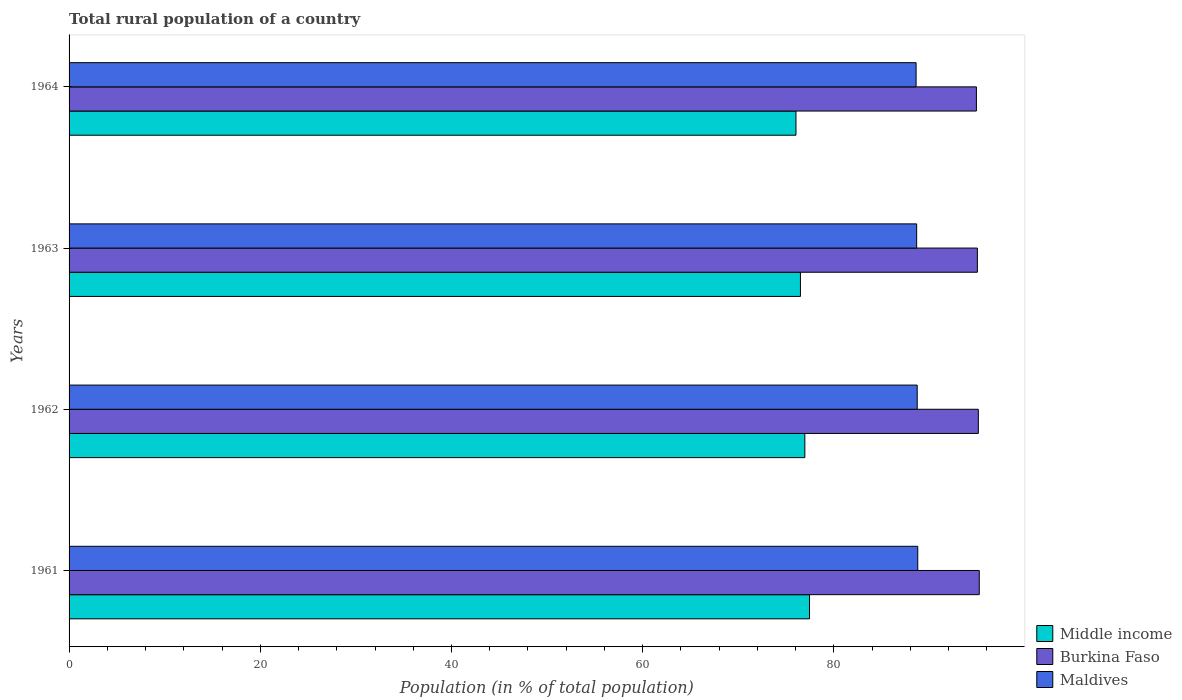How many bars are there on the 4th tick from the top?
Offer a very short reply. 3. How many bars are there on the 3rd tick from the bottom?
Your response must be concise. 3. What is the label of the 1st group of bars from the top?
Your answer should be very brief. 1964. What is the rural population in Burkina Faso in 1963?
Keep it short and to the point. 95.01. Across all years, what is the maximum rural population in Middle income?
Offer a terse response. 77.45. Across all years, what is the minimum rural population in Burkina Faso?
Your answer should be very brief. 94.91. In which year was the rural population in Maldives minimum?
Provide a succinct answer. 1964. What is the total rural population in Maldives in the graph?
Keep it short and to the point. 354.73. What is the difference between the rural population in Middle income in 1962 and that in 1963?
Keep it short and to the point. 0.46. What is the difference between the rural population in Maldives in 1962 and the rural population in Middle income in 1963?
Ensure brevity in your answer.  12.21. What is the average rural population in Burkina Faso per year?
Your response must be concise. 95.06. In the year 1964, what is the difference between the rural population in Burkina Faso and rural population in Maldives?
Make the answer very short. 6.31. In how many years, is the rural population in Maldives greater than 32 %?
Keep it short and to the point. 4. What is the ratio of the rural population in Burkina Faso in 1961 to that in 1964?
Give a very brief answer. 1. Is the rural population in Maldives in 1962 less than that in 1963?
Offer a terse response. No. What is the difference between the highest and the second highest rural population in Burkina Faso?
Your answer should be very brief. 0.1. What is the difference between the highest and the lowest rural population in Middle income?
Ensure brevity in your answer.  1.42. In how many years, is the rural population in Burkina Faso greater than the average rural population in Burkina Faso taken over all years?
Ensure brevity in your answer.  2. Is the sum of the rural population in Middle income in 1961 and 1963 greater than the maximum rural population in Burkina Faso across all years?
Make the answer very short. Yes. What does the 1st bar from the top in 1964 represents?
Give a very brief answer. Maldives. What does the 2nd bar from the bottom in 1964 represents?
Your response must be concise. Burkina Faso. How many years are there in the graph?
Your response must be concise. 4. Does the graph contain any zero values?
Ensure brevity in your answer.  No. Where does the legend appear in the graph?
Ensure brevity in your answer.  Bottom right. How are the legend labels stacked?
Keep it short and to the point. Vertical. What is the title of the graph?
Keep it short and to the point. Total rural population of a country. What is the label or title of the X-axis?
Your response must be concise. Population (in % of total population). What is the Population (in % of total population) of Middle income in 1961?
Ensure brevity in your answer.  77.45. What is the Population (in % of total population) of Burkina Faso in 1961?
Your answer should be compact. 95.2. What is the Population (in % of total population) in Maldives in 1961?
Give a very brief answer. 88.77. What is the Population (in % of total population) in Middle income in 1962?
Provide a short and direct response. 76.96. What is the Population (in % of total population) of Burkina Faso in 1962?
Ensure brevity in your answer.  95.11. What is the Population (in % of total population) in Maldives in 1962?
Ensure brevity in your answer.  88.71. What is the Population (in % of total population) in Middle income in 1963?
Your response must be concise. 76.5. What is the Population (in % of total population) of Burkina Faso in 1963?
Your answer should be compact. 95.01. What is the Population (in % of total population) in Maldives in 1963?
Provide a succinct answer. 88.66. What is the Population (in % of total population) in Middle income in 1964?
Your answer should be compact. 76.03. What is the Population (in % of total population) of Burkina Faso in 1964?
Your answer should be very brief. 94.91. What is the Population (in % of total population) of Maldives in 1964?
Give a very brief answer. 88.6. Across all years, what is the maximum Population (in % of total population) of Middle income?
Your answer should be compact. 77.45. Across all years, what is the maximum Population (in % of total population) in Burkina Faso?
Offer a terse response. 95.2. Across all years, what is the maximum Population (in % of total population) in Maldives?
Your answer should be compact. 88.77. Across all years, what is the minimum Population (in % of total population) of Middle income?
Your response must be concise. 76.03. Across all years, what is the minimum Population (in % of total population) in Burkina Faso?
Provide a short and direct response. 94.91. Across all years, what is the minimum Population (in % of total population) in Maldives?
Offer a terse response. 88.6. What is the total Population (in % of total population) in Middle income in the graph?
Provide a succinct answer. 306.94. What is the total Population (in % of total population) in Burkina Faso in the graph?
Keep it short and to the point. 380.22. What is the total Population (in % of total population) of Maldives in the graph?
Offer a very short reply. 354.73. What is the difference between the Population (in % of total population) in Middle income in 1961 and that in 1962?
Make the answer very short. 0.49. What is the difference between the Population (in % of total population) in Burkina Faso in 1961 and that in 1962?
Give a very brief answer. 0.1. What is the difference between the Population (in % of total population) in Maldives in 1961 and that in 1962?
Provide a succinct answer. 0.06. What is the difference between the Population (in % of total population) in Middle income in 1961 and that in 1963?
Provide a short and direct response. 0.95. What is the difference between the Population (in % of total population) of Burkina Faso in 1961 and that in 1963?
Offer a terse response. 0.2. What is the difference between the Population (in % of total population) in Maldives in 1961 and that in 1963?
Your answer should be very brief. 0.12. What is the difference between the Population (in % of total population) of Middle income in 1961 and that in 1964?
Your answer should be compact. 1.42. What is the difference between the Population (in % of total population) of Burkina Faso in 1961 and that in 1964?
Your response must be concise. 0.3. What is the difference between the Population (in % of total population) in Maldives in 1961 and that in 1964?
Provide a short and direct response. 0.17. What is the difference between the Population (in % of total population) of Middle income in 1962 and that in 1963?
Make the answer very short. 0.46. What is the difference between the Population (in % of total population) of Burkina Faso in 1962 and that in 1963?
Offer a very short reply. 0.1. What is the difference between the Population (in % of total population) in Maldives in 1962 and that in 1963?
Give a very brief answer. 0.06. What is the difference between the Population (in % of total population) in Middle income in 1962 and that in 1964?
Ensure brevity in your answer.  0.93. What is the difference between the Population (in % of total population) in Burkina Faso in 1962 and that in 1964?
Provide a short and direct response. 0.2. What is the difference between the Population (in % of total population) in Maldives in 1962 and that in 1964?
Provide a short and direct response. 0.12. What is the difference between the Population (in % of total population) of Middle income in 1963 and that in 1964?
Keep it short and to the point. 0.47. What is the difference between the Population (in % of total population) in Burkina Faso in 1963 and that in 1964?
Make the answer very short. 0.1. What is the difference between the Population (in % of total population) of Maldives in 1963 and that in 1964?
Keep it short and to the point. 0.06. What is the difference between the Population (in % of total population) in Middle income in 1961 and the Population (in % of total population) in Burkina Faso in 1962?
Keep it short and to the point. -17.66. What is the difference between the Population (in % of total population) of Middle income in 1961 and the Population (in % of total population) of Maldives in 1962?
Make the answer very short. -11.27. What is the difference between the Population (in % of total population) of Burkina Faso in 1961 and the Population (in % of total population) of Maldives in 1962?
Offer a very short reply. 6.49. What is the difference between the Population (in % of total population) of Middle income in 1961 and the Population (in % of total population) of Burkina Faso in 1963?
Your answer should be compact. -17.56. What is the difference between the Population (in % of total population) of Middle income in 1961 and the Population (in % of total population) of Maldives in 1963?
Make the answer very short. -11.21. What is the difference between the Population (in % of total population) of Burkina Faso in 1961 and the Population (in % of total population) of Maldives in 1963?
Offer a very short reply. 6.55. What is the difference between the Population (in % of total population) of Middle income in 1961 and the Population (in % of total population) of Burkina Faso in 1964?
Offer a very short reply. -17.46. What is the difference between the Population (in % of total population) in Middle income in 1961 and the Population (in % of total population) in Maldives in 1964?
Make the answer very short. -11.15. What is the difference between the Population (in % of total population) in Burkina Faso in 1961 and the Population (in % of total population) in Maldives in 1964?
Keep it short and to the point. 6.61. What is the difference between the Population (in % of total population) in Middle income in 1962 and the Population (in % of total population) in Burkina Faso in 1963?
Keep it short and to the point. -18.05. What is the difference between the Population (in % of total population) of Middle income in 1962 and the Population (in % of total population) of Maldives in 1963?
Offer a very short reply. -11.69. What is the difference between the Population (in % of total population) in Burkina Faso in 1962 and the Population (in % of total population) in Maldives in 1963?
Offer a very short reply. 6.45. What is the difference between the Population (in % of total population) of Middle income in 1962 and the Population (in % of total population) of Burkina Faso in 1964?
Give a very brief answer. -17.94. What is the difference between the Population (in % of total population) of Middle income in 1962 and the Population (in % of total population) of Maldives in 1964?
Offer a terse response. -11.64. What is the difference between the Population (in % of total population) in Burkina Faso in 1962 and the Population (in % of total population) in Maldives in 1964?
Offer a terse response. 6.51. What is the difference between the Population (in % of total population) in Middle income in 1963 and the Population (in % of total population) in Burkina Faso in 1964?
Your response must be concise. -18.4. What is the difference between the Population (in % of total population) of Middle income in 1963 and the Population (in % of total population) of Maldives in 1964?
Provide a short and direct response. -12.1. What is the difference between the Population (in % of total population) in Burkina Faso in 1963 and the Population (in % of total population) in Maldives in 1964?
Give a very brief answer. 6.41. What is the average Population (in % of total population) in Middle income per year?
Ensure brevity in your answer.  76.73. What is the average Population (in % of total population) in Burkina Faso per year?
Offer a terse response. 95.06. What is the average Population (in % of total population) of Maldives per year?
Keep it short and to the point. 88.68. In the year 1961, what is the difference between the Population (in % of total population) of Middle income and Population (in % of total population) of Burkina Faso?
Ensure brevity in your answer.  -17.76. In the year 1961, what is the difference between the Population (in % of total population) of Middle income and Population (in % of total population) of Maldives?
Make the answer very short. -11.32. In the year 1961, what is the difference between the Population (in % of total population) of Burkina Faso and Population (in % of total population) of Maldives?
Provide a succinct answer. 6.43. In the year 1962, what is the difference between the Population (in % of total population) of Middle income and Population (in % of total population) of Burkina Faso?
Your answer should be very brief. -18.15. In the year 1962, what is the difference between the Population (in % of total population) of Middle income and Population (in % of total population) of Maldives?
Provide a succinct answer. -11.75. In the year 1962, what is the difference between the Population (in % of total population) in Burkina Faso and Population (in % of total population) in Maldives?
Make the answer very short. 6.39. In the year 1963, what is the difference between the Population (in % of total population) in Middle income and Population (in % of total population) in Burkina Faso?
Provide a short and direct response. -18.51. In the year 1963, what is the difference between the Population (in % of total population) of Middle income and Population (in % of total population) of Maldives?
Keep it short and to the point. -12.15. In the year 1963, what is the difference between the Population (in % of total population) of Burkina Faso and Population (in % of total population) of Maldives?
Offer a terse response. 6.35. In the year 1964, what is the difference between the Population (in % of total population) of Middle income and Population (in % of total population) of Burkina Faso?
Your answer should be compact. -18.87. In the year 1964, what is the difference between the Population (in % of total population) of Middle income and Population (in % of total population) of Maldives?
Your answer should be compact. -12.56. In the year 1964, what is the difference between the Population (in % of total population) of Burkina Faso and Population (in % of total population) of Maldives?
Offer a very short reply. 6.31. What is the ratio of the Population (in % of total population) in Middle income in 1961 to that in 1962?
Offer a terse response. 1.01. What is the ratio of the Population (in % of total population) of Burkina Faso in 1961 to that in 1962?
Offer a terse response. 1. What is the ratio of the Population (in % of total population) of Maldives in 1961 to that in 1962?
Your answer should be compact. 1. What is the ratio of the Population (in % of total population) of Middle income in 1961 to that in 1963?
Give a very brief answer. 1.01. What is the ratio of the Population (in % of total population) of Middle income in 1961 to that in 1964?
Give a very brief answer. 1.02. What is the ratio of the Population (in % of total population) in Middle income in 1962 to that in 1963?
Provide a short and direct response. 1.01. What is the ratio of the Population (in % of total population) in Burkina Faso in 1962 to that in 1963?
Provide a succinct answer. 1. What is the ratio of the Population (in % of total population) of Middle income in 1962 to that in 1964?
Your response must be concise. 1.01. What is the ratio of the Population (in % of total population) in Maldives in 1962 to that in 1964?
Offer a very short reply. 1. What is the ratio of the Population (in % of total population) in Middle income in 1963 to that in 1964?
Your answer should be very brief. 1.01. What is the difference between the highest and the second highest Population (in % of total population) in Middle income?
Your answer should be very brief. 0.49. What is the difference between the highest and the second highest Population (in % of total population) in Burkina Faso?
Ensure brevity in your answer.  0.1. What is the difference between the highest and the second highest Population (in % of total population) in Maldives?
Offer a very short reply. 0.06. What is the difference between the highest and the lowest Population (in % of total population) in Middle income?
Provide a succinct answer. 1.42. What is the difference between the highest and the lowest Population (in % of total population) of Burkina Faso?
Your response must be concise. 0.3. What is the difference between the highest and the lowest Population (in % of total population) in Maldives?
Your response must be concise. 0.17. 